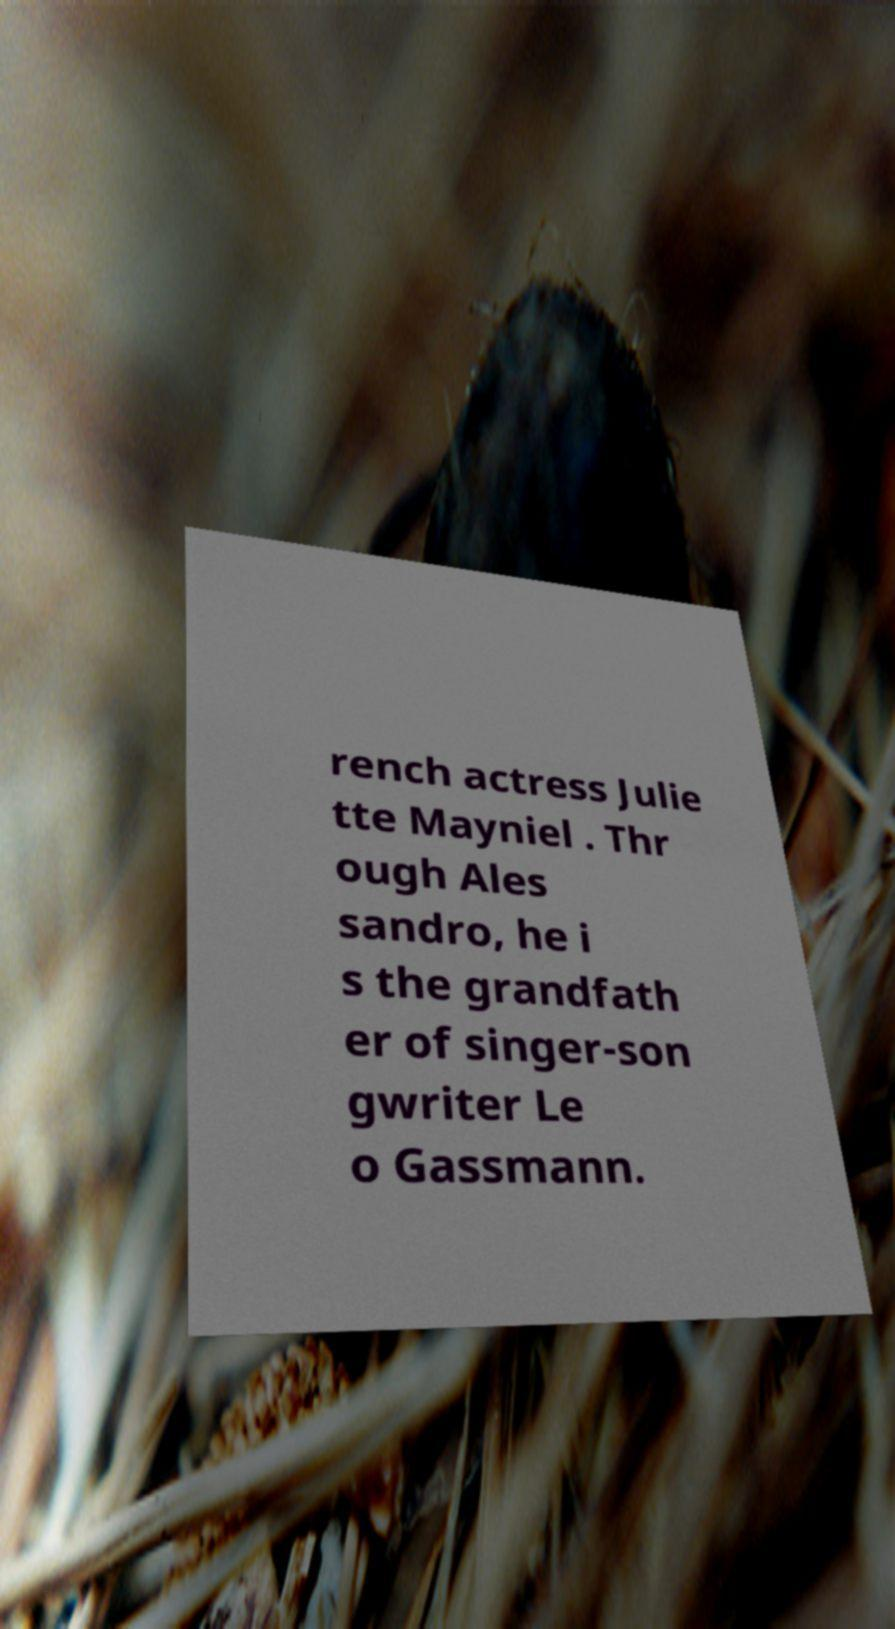Can you read and provide the text displayed in the image?This photo seems to have some interesting text. Can you extract and type it out for me? rench actress Julie tte Mayniel . Thr ough Ales sandro, he i s the grandfath er of singer-son gwriter Le o Gassmann. 